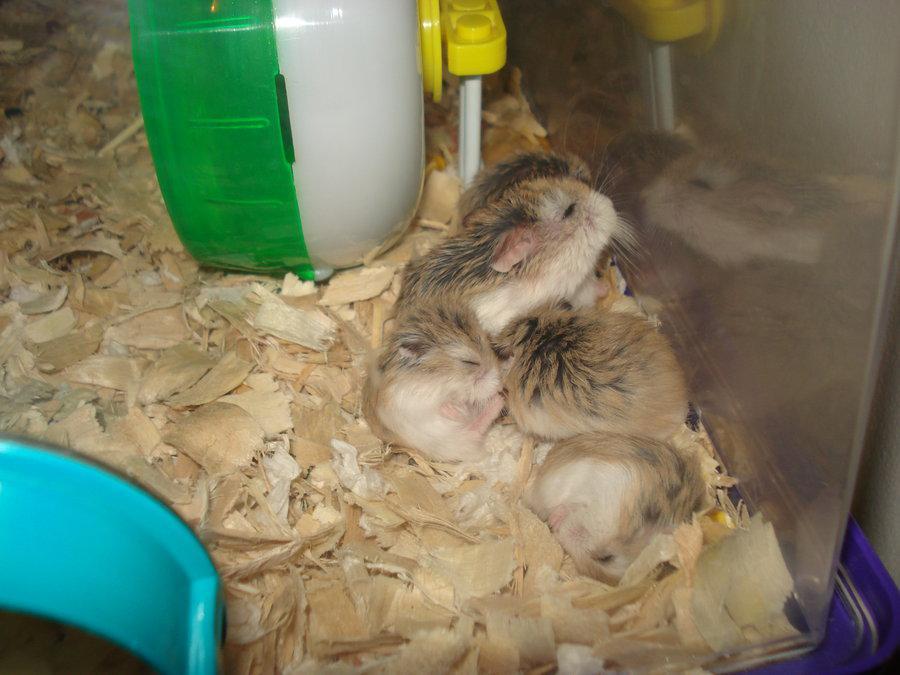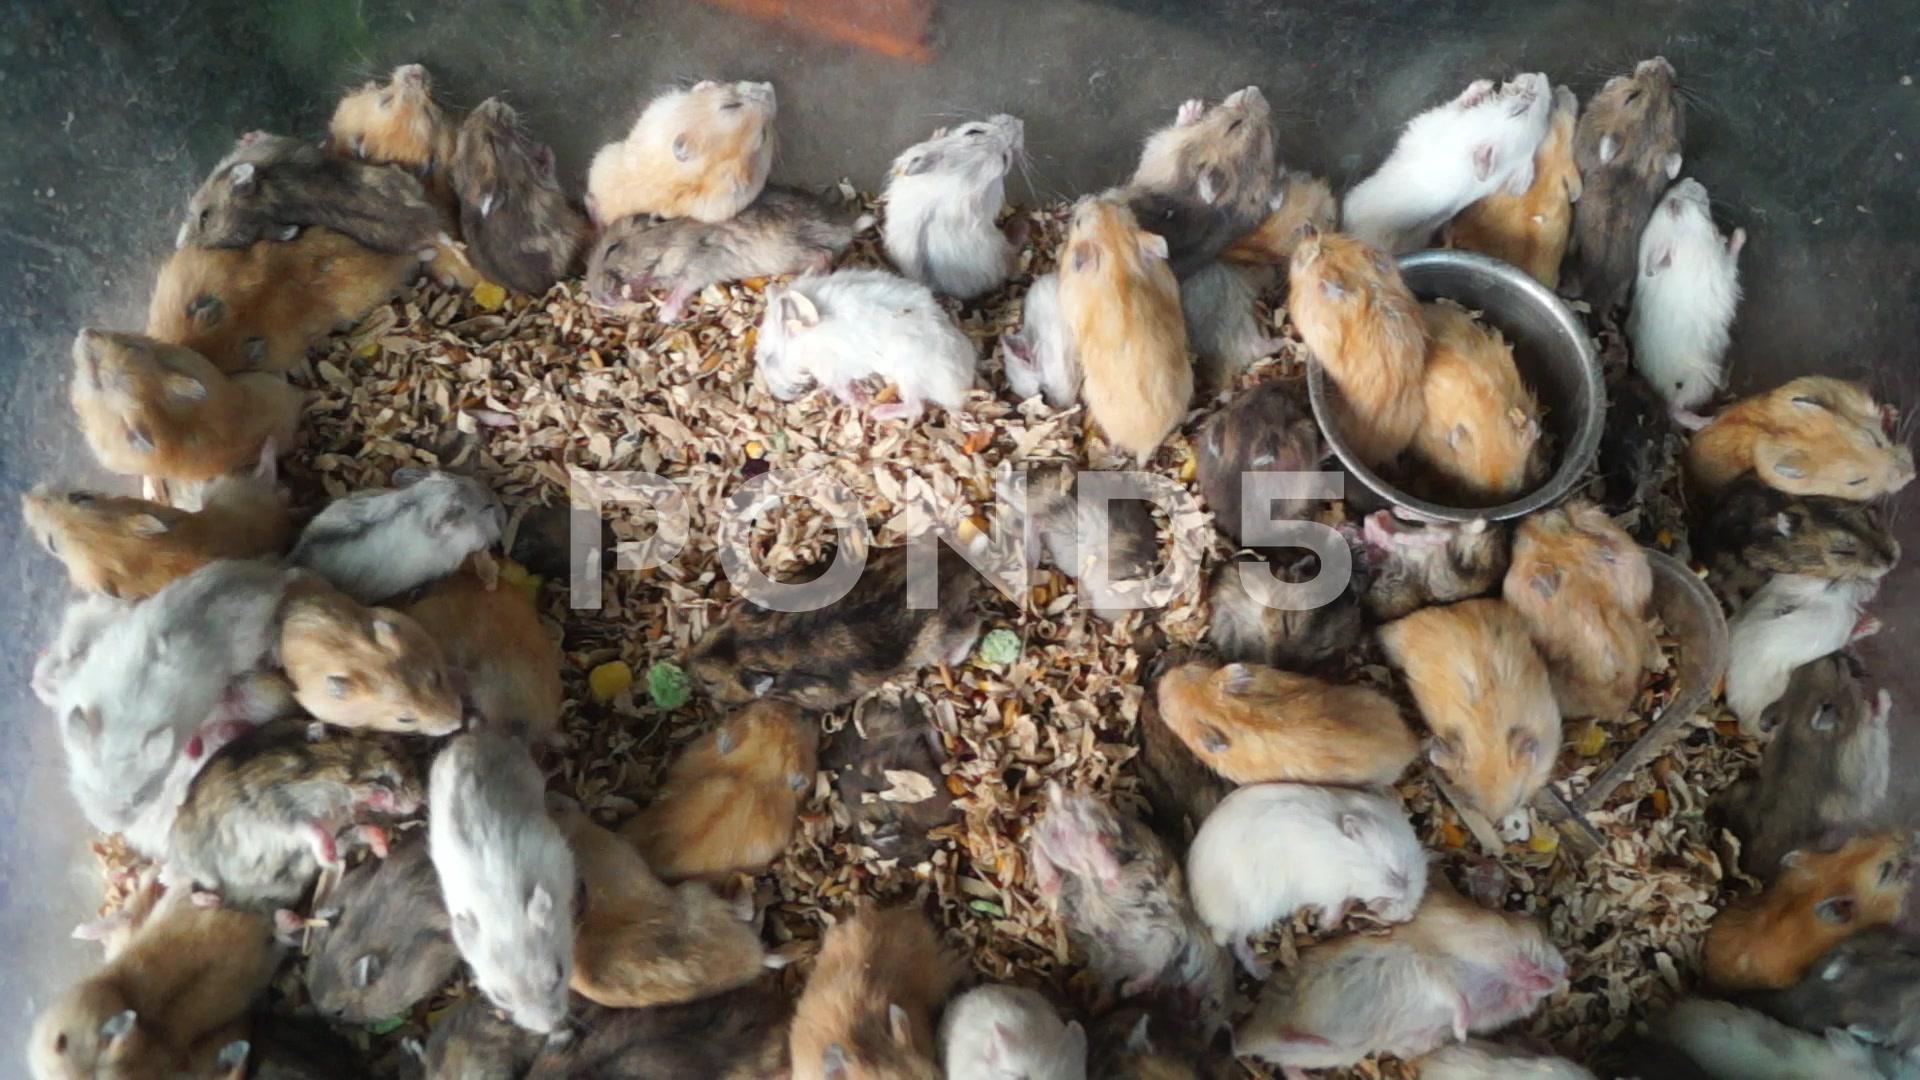The first image is the image on the left, the second image is the image on the right. Evaluate the accuracy of this statement regarding the images: "There are more hamsters in the image on the right than on the left.". Is it true? Answer yes or no. Yes. 